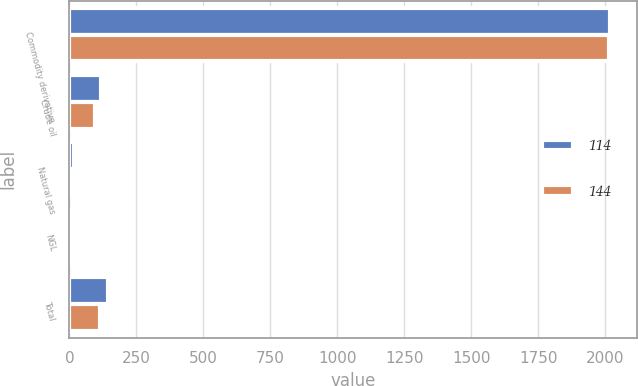Convert chart. <chart><loc_0><loc_0><loc_500><loc_500><stacked_bar_chart><ecel><fcel>Commodity derivative<fcel>Crude oil<fcel>Natural gas<fcel>NGL<fcel>Total<nl><fcel>114<fcel>2016<fcel>117<fcel>16<fcel>11<fcel>144<nl><fcel>144<fcel>2015<fcel>97<fcel>13<fcel>4<fcel>114<nl></chart> 